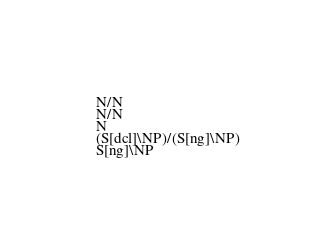<code> <loc_0><loc_0><loc_500><loc_500><_C_>N/N
N/N
N
(S[dcl]\NP)/(S[ng]\NP)
S[ng]\NP
</code> 